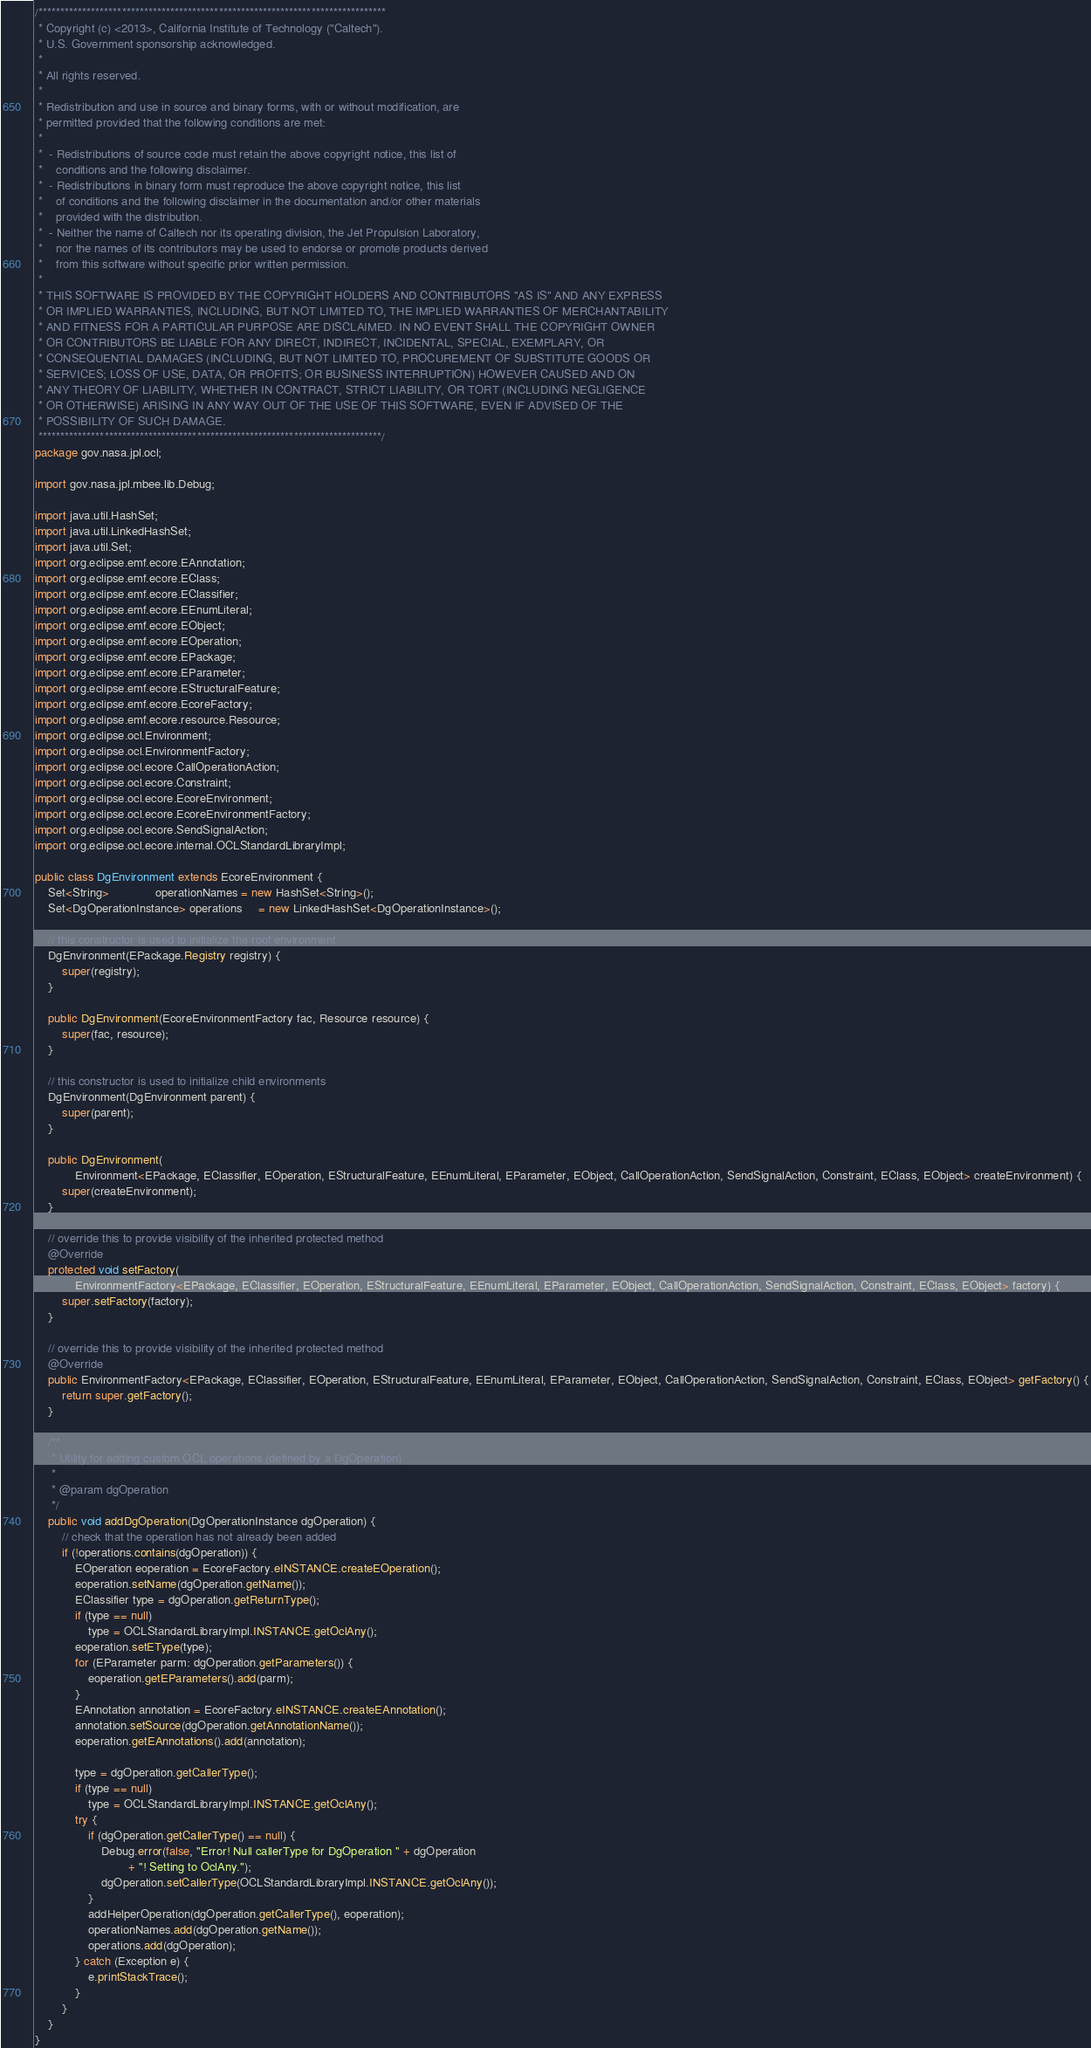Convert code to text. <code><loc_0><loc_0><loc_500><loc_500><_Java_>/*******************************************************************************
 * Copyright (c) <2013>, California Institute of Technology ("Caltech").  
 * U.S. Government sponsorship acknowledged.
 * 
 * All rights reserved.
 * 
 * Redistribution and use in source and binary forms, with or without modification, are 
 * permitted provided that the following conditions are met:
 * 
 *  - Redistributions of source code must retain the above copyright notice, this list of 
 *    conditions and the following disclaimer.
 *  - Redistributions in binary form must reproduce the above copyright notice, this list 
 *    of conditions and the following disclaimer in the documentation and/or other materials 
 *    provided with the distribution.
 *  - Neither the name of Caltech nor its operating division, the Jet Propulsion Laboratory, 
 *    nor the names of its contributors may be used to endorse or promote products derived 
 *    from this software without specific prior written permission.
 * 
 * THIS SOFTWARE IS PROVIDED BY THE COPYRIGHT HOLDERS AND CONTRIBUTORS "AS IS" AND ANY EXPRESS 
 * OR IMPLIED WARRANTIES, INCLUDING, BUT NOT LIMITED TO, THE IMPLIED WARRANTIES OF MERCHANTABILITY 
 * AND FITNESS FOR A PARTICULAR PURPOSE ARE DISCLAIMED. IN NO EVENT SHALL THE COPYRIGHT OWNER  
 * OR CONTRIBUTORS BE LIABLE FOR ANY DIRECT, INDIRECT, INCIDENTAL, SPECIAL, EXEMPLARY, OR 
 * CONSEQUENTIAL DAMAGES (INCLUDING, BUT NOT LIMITED TO, PROCUREMENT OF SUBSTITUTE GOODS OR 
 * SERVICES; LOSS OF USE, DATA, OR PROFITS; OR BUSINESS INTERRUPTION) HOWEVER CAUSED AND ON 
 * ANY THEORY OF LIABILITY, WHETHER IN CONTRACT, STRICT LIABILITY, OR TORT (INCLUDING NEGLIGENCE 
 * OR OTHERWISE) ARISING IN ANY WAY OUT OF THE USE OF THIS SOFTWARE, EVEN IF ADVISED OF THE 
 * POSSIBILITY OF SUCH DAMAGE.
 ******************************************************************************/
package gov.nasa.jpl.ocl;

import gov.nasa.jpl.mbee.lib.Debug;

import java.util.HashSet;
import java.util.LinkedHashSet;
import java.util.Set;
import org.eclipse.emf.ecore.EAnnotation;
import org.eclipse.emf.ecore.EClass;
import org.eclipse.emf.ecore.EClassifier;
import org.eclipse.emf.ecore.EEnumLiteral;
import org.eclipse.emf.ecore.EObject;
import org.eclipse.emf.ecore.EOperation;
import org.eclipse.emf.ecore.EPackage;
import org.eclipse.emf.ecore.EParameter;
import org.eclipse.emf.ecore.EStructuralFeature;
import org.eclipse.emf.ecore.EcoreFactory;
import org.eclipse.emf.ecore.resource.Resource;
import org.eclipse.ocl.Environment;
import org.eclipse.ocl.EnvironmentFactory;
import org.eclipse.ocl.ecore.CallOperationAction;
import org.eclipse.ocl.ecore.Constraint;
import org.eclipse.ocl.ecore.EcoreEnvironment;
import org.eclipse.ocl.ecore.EcoreEnvironmentFactory;
import org.eclipse.ocl.ecore.SendSignalAction;
import org.eclipse.ocl.ecore.internal.OCLStandardLibraryImpl;

public class DgEnvironment extends EcoreEnvironment {
    Set<String>              operationNames = new HashSet<String>();
    Set<DgOperationInstance> operations     = new LinkedHashSet<DgOperationInstance>();

    // this constructor is used to initialize the root environment
    DgEnvironment(EPackage.Registry registry) {
        super(registry);
    }

    public DgEnvironment(EcoreEnvironmentFactory fac, Resource resource) {
        super(fac, resource);
    }

    // this constructor is used to initialize child environments
    DgEnvironment(DgEnvironment parent) {
        super(parent);
    }

    public DgEnvironment(
            Environment<EPackage, EClassifier, EOperation, EStructuralFeature, EEnumLiteral, EParameter, EObject, CallOperationAction, SendSignalAction, Constraint, EClass, EObject> createEnvironment) {
        super(createEnvironment);
    }

    // override this to provide visibility of the inherited protected method
    @Override
    protected void setFactory(
            EnvironmentFactory<EPackage, EClassifier, EOperation, EStructuralFeature, EEnumLiteral, EParameter, EObject, CallOperationAction, SendSignalAction, Constraint, EClass, EObject> factory) {
        super.setFactory(factory);
    }

    // override this to provide visibility of the inherited protected method
    @Override
    public EnvironmentFactory<EPackage, EClassifier, EOperation, EStructuralFeature, EEnumLiteral, EParameter, EObject, CallOperationAction, SendSignalAction, Constraint, EClass, EObject> getFactory() {
        return super.getFactory();
    }

    /**
     * Utility for adding custom OCL operations (defined by a DgOperation)
     * 
     * @param dgOperation
     */
    public void addDgOperation(DgOperationInstance dgOperation) {
        // check that the operation has not already been added
        if (!operations.contains(dgOperation)) {
            EOperation eoperation = EcoreFactory.eINSTANCE.createEOperation();
            eoperation.setName(dgOperation.getName());
            EClassifier type = dgOperation.getReturnType();
            if (type == null)
                type = OCLStandardLibraryImpl.INSTANCE.getOclAny();
            eoperation.setEType(type);
            for (EParameter parm: dgOperation.getParameters()) {
                eoperation.getEParameters().add(parm);
            }
            EAnnotation annotation = EcoreFactory.eINSTANCE.createEAnnotation();
            annotation.setSource(dgOperation.getAnnotationName());
            eoperation.getEAnnotations().add(annotation);

            type = dgOperation.getCallerType();
            if (type == null)
                type = OCLStandardLibraryImpl.INSTANCE.getOclAny();
            try {
                if (dgOperation.getCallerType() == null) {
                    Debug.error(false, "Error! Null callerType for DgOperation " + dgOperation
                            + "! Setting to OclAny.");
                    dgOperation.setCallerType(OCLStandardLibraryImpl.INSTANCE.getOclAny());
                }
                addHelperOperation(dgOperation.getCallerType(), eoperation);
                operationNames.add(dgOperation.getName());
                operations.add(dgOperation);
            } catch (Exception e) {
                e.printStackTrace();
            }
        }
    }
}
</code> 